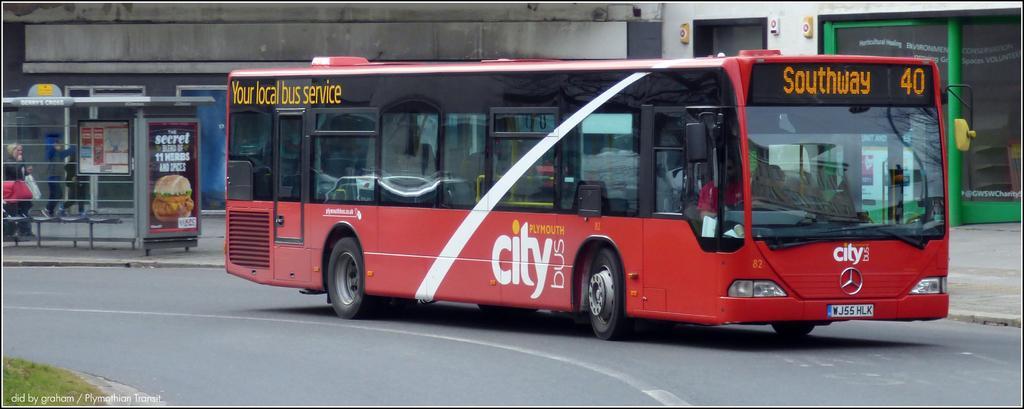How would you summarize this image in a sentence or two? In this image we can see a person sitting inside a bus placed on the road. To the left side of the image we can see a hoarding with some text and a photo on it. One woman is carrying a bag and one person is standing on the path. In the background of the image we can see a building with windows and door. 